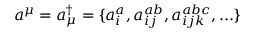Convert formula to latex. <formula><loc_0><loc_0><loc_500><loc_500>a ^ { \mu } = a _ { \mu } ^ { \dagger } = \{ a _ { i } ^ { a } , a _ { i j } ^ { a b } , a _ { i j k } ^ { a b c } , \dots \}</formula> 